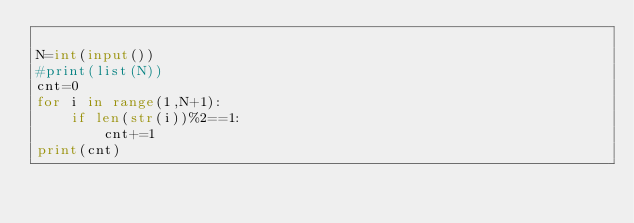Convert code to text. <code><loc_0><loc_0><loc_500><loc_500><_Python_>
N=int(input())
#print(list(N))
cnt=0
for i in range(1,N+1):
    if len(str(i))%2==1:
        cnt+=1
print(cnt)</code> 